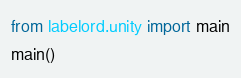<code> <loc_0><loc_0><loc_500><loc_500><_Python_>from labelord.unity import main
main()
</code> 